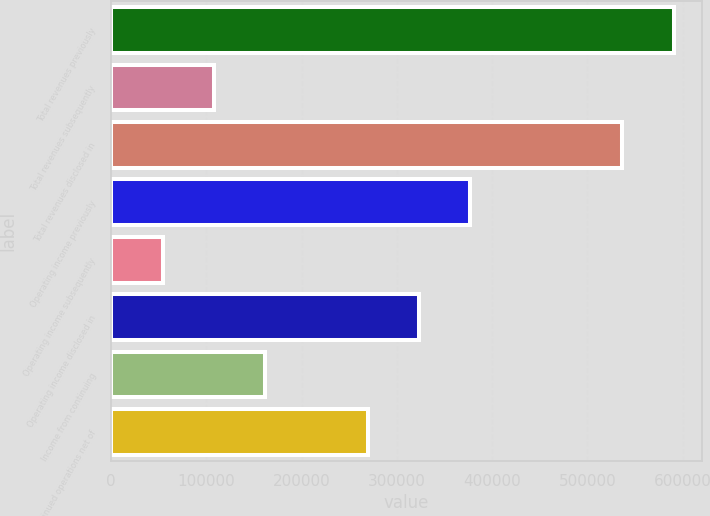<chart> <loc_0><loc_0><loc_500><loc_500><bar_chart><fcel>Total revenues previously<fcel>Total revenues subsequently<fcel>Total revenues disclosed in<fcel>Operating income previously<fcel>Operating income subsequently<fcel>Operating income disclosed in<fcel>Income from continuing<fcel>Discontinued operations net of<nl><fcel>590619<fcel>108194<fcel>536853<fcel>377022<fcel>54428.6<fcel>323257<fcel>161960<fcel>269491<nl></chart> 